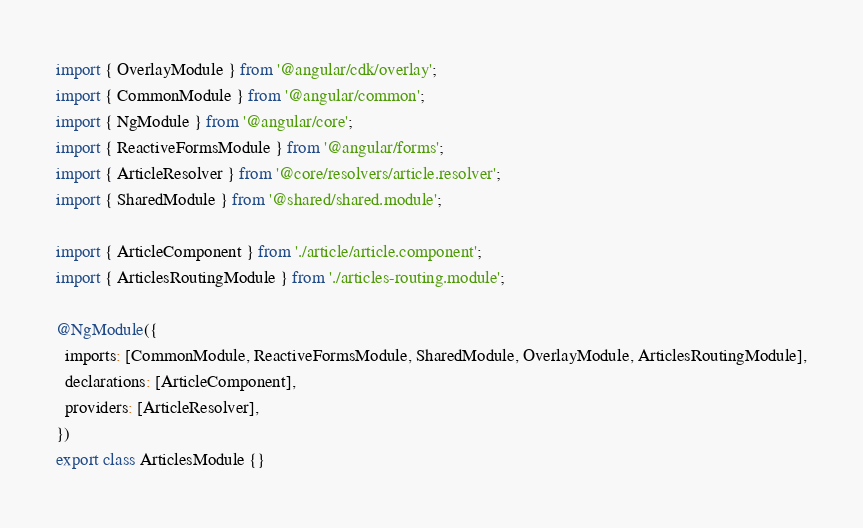<code> <loc_0><loc_0><loc_500><loc_500><_TypeScript_>import { OverlayModule } from '@angular/cdk/overlay';
import { CommonModule } from '@angular/common';
import { NgModule } from '@angular/core';
import { ReactiveFormsModule } from '@angular/forms';
import { ArticleResolver } from '@core/resolvers/article.resolver';
import { SharedModule } from '@shared/shared.module';

import { ArticleComponent } from './article/article.component';
import { ArticlesRoutingModule } from './articles-routing.module';

@NgModule({
  imports: [CommonModule, ReactiveFormsModule, SharedModule, OverlayModule, ArticlesRoutingModule],
  declarations: [ArticleComponent],
  providers: [ArticleResolver],
})
export class ArticlesModule {}
</code> 